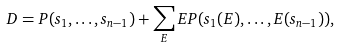<formula> <loc_0><loc_0><loc_500><loc_500>D = P ( s _ { 1 } , \dots , s _ { n - 1 } ) + \sum _ { E } E P ( s _ { 1 } ( E ) , \dots , E ( s _ { n - 1 } ) ) ,</formula> 